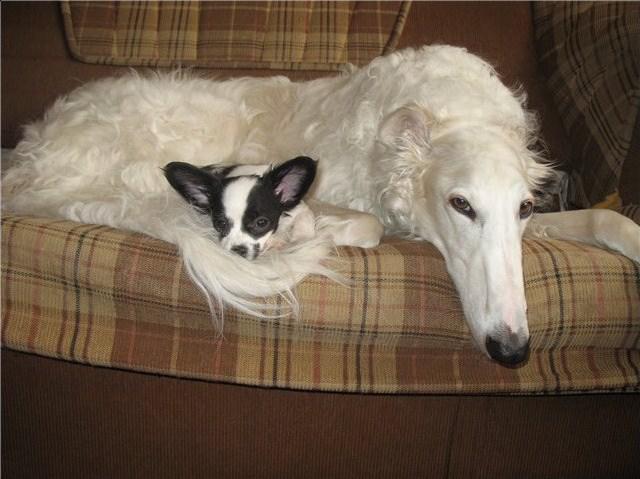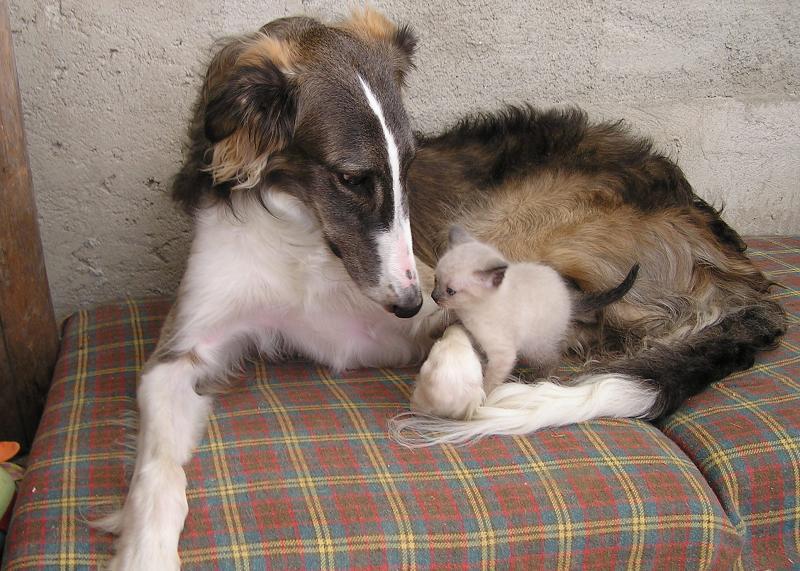The first image is the image on the left, the second image is the image on the right. For the images displayed, is the sentence "There is exactly one sleeping dog wearing a collar." factually correct? Answer yes or no. No. 